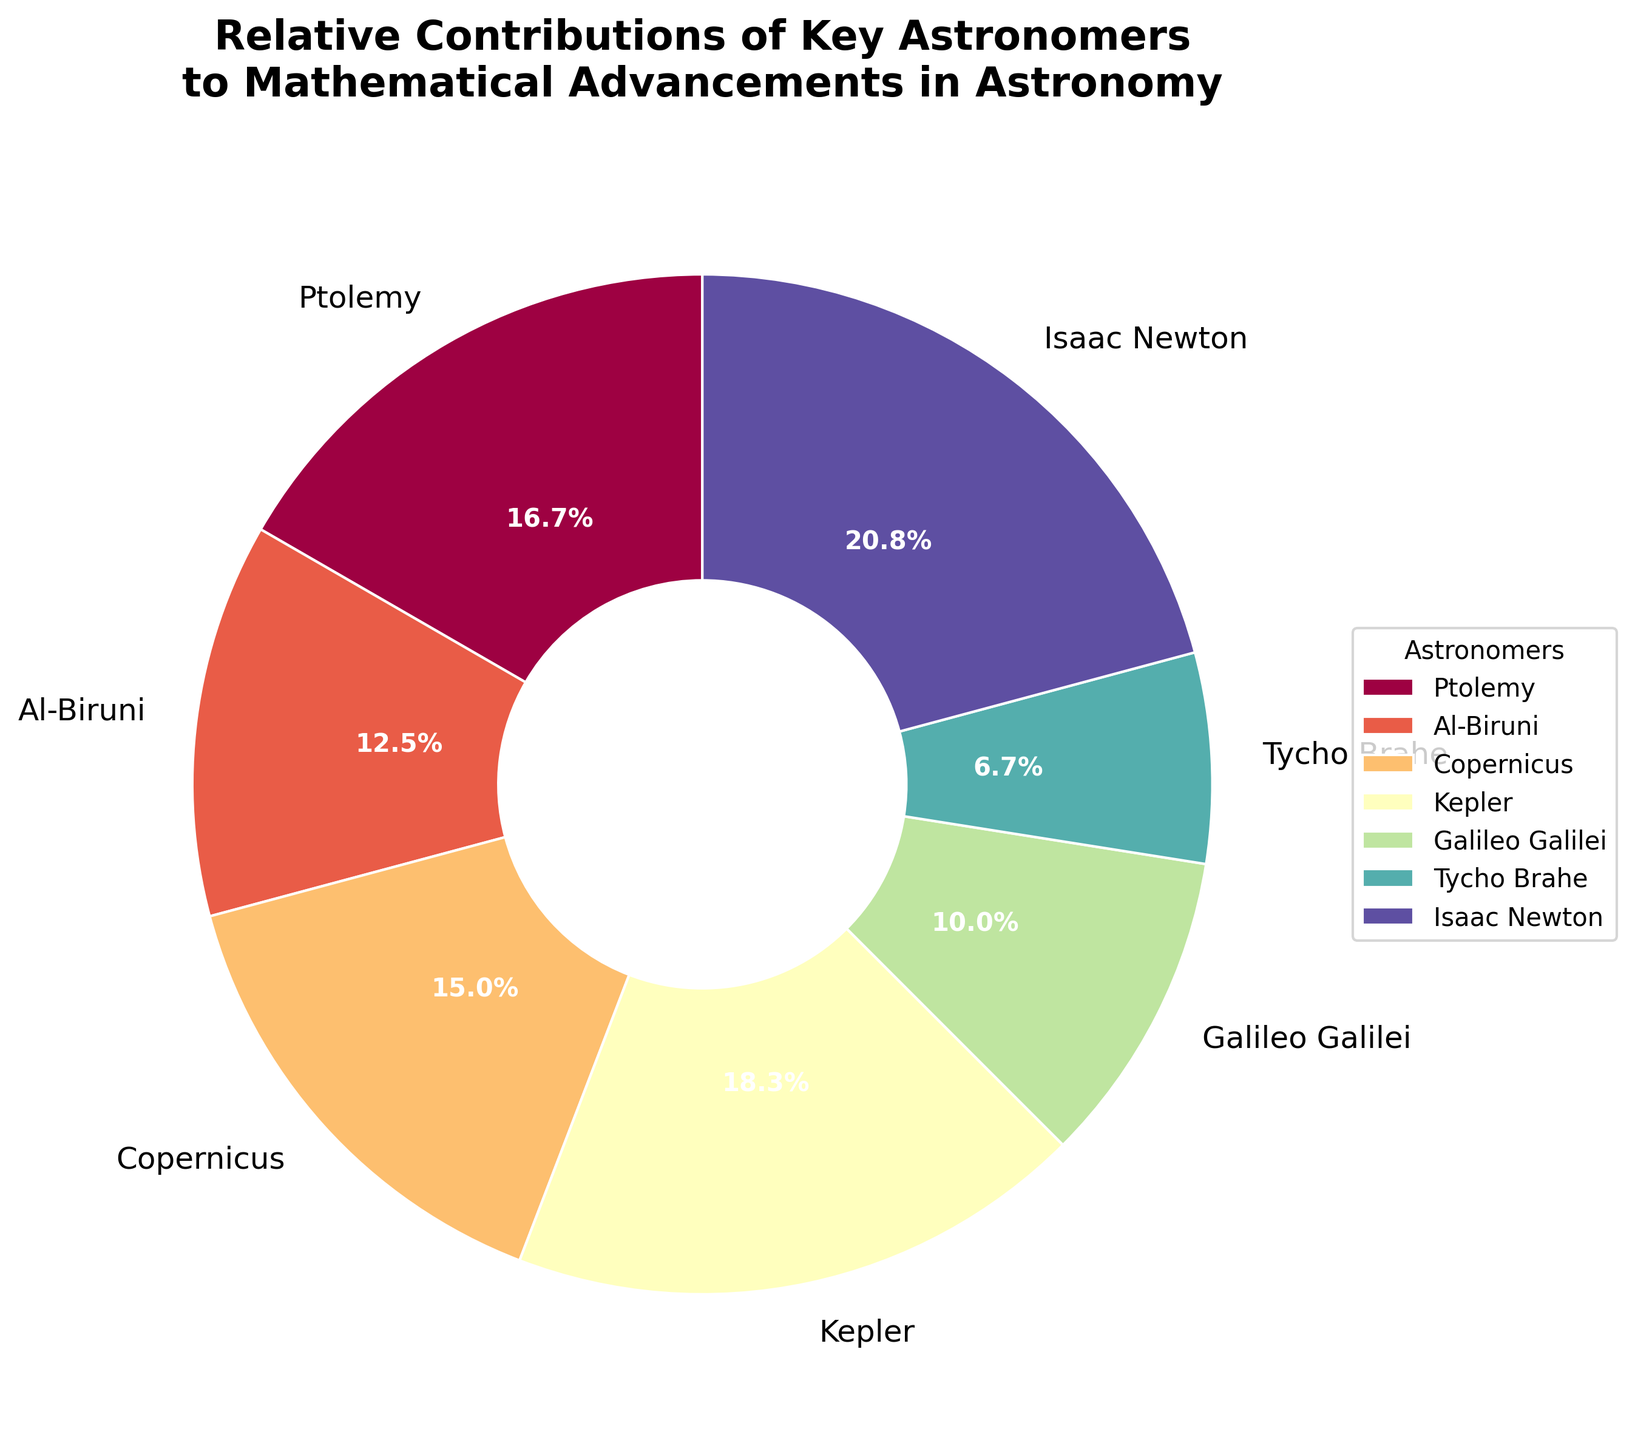Which astronomer contributed the most to mathematical advancements in astronomy? By observing the pie chart, the astronomer with the largest wedge represents the greatest contribution. Isaac Newton's segment is the largest.
Answer: Isaac Newton What's the combined contribution percentage of Copernicus and Kepler? From the pie chart, Copernicus's contribution is 18% and Kepler's contribution is 22%. Adding these together gives 18% + 22% = 40%.
Answer: 40% Between Ptolemy and Al-Biruni, who contributed less to mathematical advancements? By looking at the wedges, Ptolemy's contribution is 20% and Al-Biruni's is 15%. Hence, Al-Biruni contributed less.
Answer: Al-Biruni What's the difference in contribution percentage between Galileo Galilei and Tycho Brahe? Galileo's contribution is 12%, and Tycho Brahe's is 8%. Subtracting Tycho's contribution from Galileo's gives 12% - 8% = 4%.
Answer: 4% Which slice of the pie chart is displayed in green? Slides of pie charts are colored differently. To identify the segment color visually representing an astronomer, we spot the green segment.
Answer: Visual identification is necessary and answer may vary depending on specific rendering Who has a smaller contribution: Ptolemy or Copernicus? Observing the pie chart, Ptolemy's section represents a 20% contribution, while Copernicus's contribution is 18%, indicating Copernicus has the smaller contribution.
Answer: Copernicus What's the total percentage contribution of astronomers with more than 20%? Isaac Newton and Kepler each have contributions of 25% and 22%, respectively. Summing these, 25% + 22% = 47%.
Answer: 47% Compare the contributions of Al-Biruni and Galileo Galilei in terms of their ratio. Al-Biruni’s contribution is 15%, and Galileo's is 12%. Their ratio can be calculated as 15% ÷ 12% = 1.25.
Answer: 1.25 Who are the astronomers with the three smallest contributions, and what is their total combined contribution? By examining the smallest wedges, the astronomers with the least contributions are Tycho Brahe (8%), Galileo Galilei (12%), and Al-Biruni (15%). Adding their contributions results in 8% + 12% + 15% = 35%.
Answer: Tycho Brahe, Galileo Galilei, Al-Biruni, 35% Which astronomer has a larger contribution: Tycho Brahe or Al-Biruni? From the chart, Tycho Brahe's contribution is 8% and Al-Biruni's is 15%. Al-Biruni's contribution is larger.
Answer: Al-Biruni 